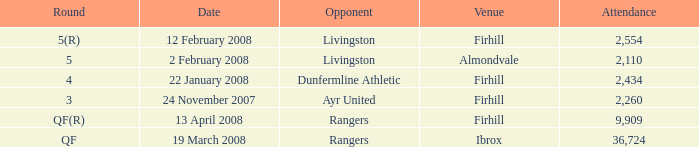Who was the opponent at the qf(r) round? Rangers. 